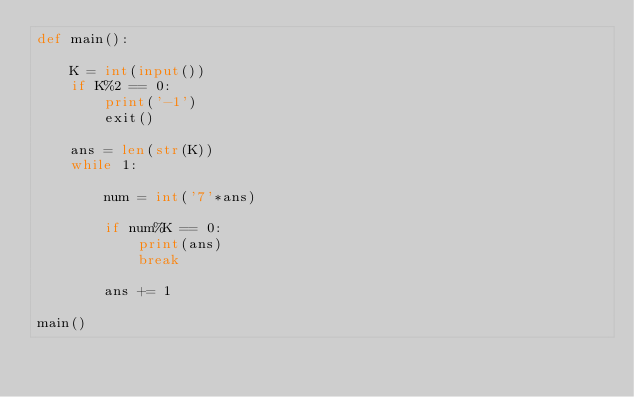<code> <loc_0><loc_0><loc_500><loc_500><_Python_>def main():
    
    K = int(input())
    if K%2 == 0:
        print('-1')
        exit()
    
    ans = len(str(K))
    while 1:
        
        num = int('7'*ans)
        
        if num%K == 0:
            print(ans)
            break
        
        ans += 1

main()</code> 